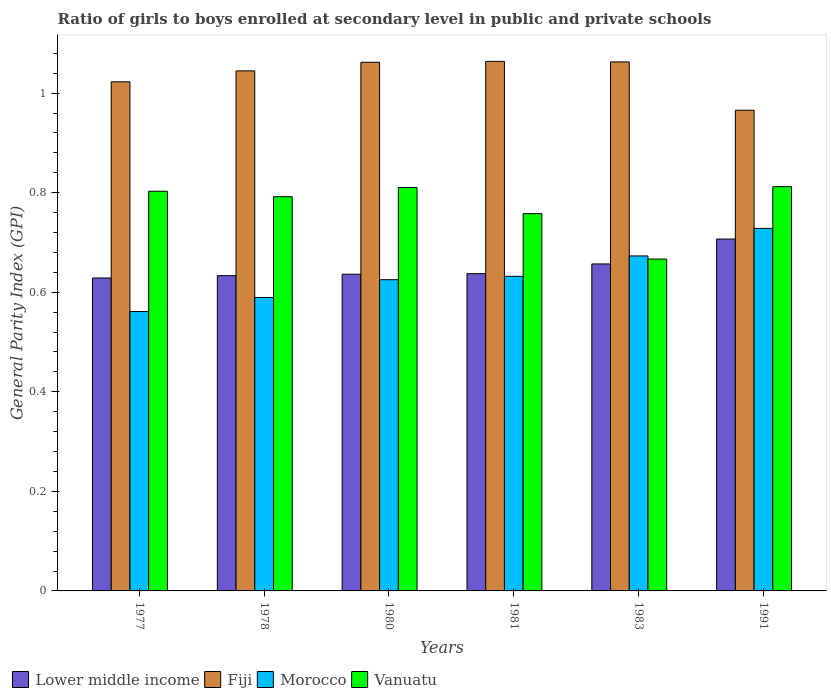What is the label of the 2nd group of bars from the left?
Offer a very short reply. 1978. What is the general parity index in Fiji in 1981?
Give a very brief answer. 1.06. Across all years, what is the maximum general parity index in Fiji?
Give a very brief answer. 1.06. Across all years, what is the minimum general parity index in Fiji?
Keep it short and to the point. 0.97. In which year was the general parity index in Lower middle income maximum?
Your answer should be compact. 1991. What is the total general parity index in Lower middle income in the graph?
Offer a very short reply. 3.9. What is the difference between the general parity index in Lower middle income in 1983 and that in 1991?
Offer a terse response. -0.05. What is the difference between the general parity index in Fiji in 1977 and the general parity index in Vanuatu in 1980?
Ensure brevity in your answer.  0.21. What is the average general parity index in Morocco per year?
Keep it short and to the point. 0.63. In the year 1983, what is the difference between the general parity index in Fiji and general parity index in Morocco?
Your answer should be very brief. 0.39. What is the ratio of the general parity index in Fiji in 1977 to that in 1983?
Keep it short and to the point. 0.96. Is the general parity index in Fiji in 1980 less than that in 1981?
Your answer should be compact. Yes. Is the difference between the general parity index in Fiji in 1977 and 1980 greater than the difference between the general parity index in Morocco in 1977 and 1980?
Offer a very short reply. Yes. What is the difference between the highest and the second highest general parity index in Vanuatu?
Ensure brevity in your answer.  0. What is the difference between the highest and the lowest general parity index in Vanuatu?
Your answer should be compact. 0.15. Is it the case that in every year, the sum of the general parity index in Morocco and general parity index in Vanuatu is greater than the sum of general parity index in Lower middle income and general parity index in Fiji?
Your response must be concise. Yes. What does the 1st bar from the left in 1978 represents?
Your answer should be compact. Lower middle income. What does the 1st bar from the right in 1991 represents?
Your answer should be very brief. Vanuatu. Is it the case that in every year, the sum of the general parity index in Lower middle income and general parity index in Fiji is greater than the general parity index in Morocco?
Keep it short and to the point. Yes. How many bars are there?
Offer a very short reply. 24. How many years are there in the graph?
Ensure brevity in your answer.  6. Are the values on the major ticks of Y-axis written in scientific E-notation?
Provide a short and direct response. No. Does the graph contain grids?
Keep it short and to the point. No. Where does the legend appear in the graph?
Provide a short and direct response. Bottom left. How are the legend labels stacked?
Your answer should be compact. Horizontal. What is the title of the graph?
Your answer should be compact. Ratio of girls to boys enrolled at secondary level in public and private schools. What is the label or title of the X-axis?
Make the answer very short. Years. What is the label or title of the Y-axis?
Provide a short and direct response. General Parity Index (GPI). What is the General Parity Index (GPI) in Lower middle income in 1977?
Ensure brevity in your answer.  0.63. What is the General Parity Index (GPI) of Fiji in 1977?
Ensure brevity in your answer.  1.02. What is the General Parity Index (GPI) of Morocco in 1977?
Provide a short and direct response. 0.56. What is the General Parity Index (GPI) in Vanuatu in 1977?
Your response must be concise. 0.8. What is the General Parity Index (GPI) of Lower middle income in 1978?
Give a very brief answer. 0.63. What is the General Parity Index (GPI) of Fiji in 1978?
Ensure brevity in your answer.  1.04. What is the General Parity Index (GPI) of Morocco in 1978?
Keep it short and to the point. 0.59. What is the General Parity Index (GPI) of Vanuatu in 1978?
Offer a terse response. 0.79. What is the General Parity Index (GPI) in Lower middle income in 1980?
Give a very brief answer. 0.64. What is the General Parity Index (GPI) of Fiji in 1980?
Provide a short and direct response. 1.06. What is the General Parity Index (GPI) in Morocco in 1980?
Offer a very short reply. 0.63. What is the General Parity Index (GPI) in Vanuatu in 1980?
Ensure brevity in your answer.  0.81. What is the General Parity Index (GPI) of Lower middle income in 1981?
Offer a very short reply. 0.64. What is the General Parity Index (GPI) in Fiji in 1981?
Make the answer very short. 1.06. What is the General Parity Index (GPI) in Morocco in 1981?
Your response must be concise. 0.63. What is the General Parity Index (GPI) of Vanuatu in 1981?
Provide a short and direct response. 0.76. What is the General Parity Index (GPI) in Lower middle income in 1983?
Give a very brief answer. 0.66. What is the General Parity Index (GPI) of Fiji in 1983?
Provide a short and direct response. 1.06. What is the General Parity Index (GPI) in Morocco in 1983?
Your answer should be compact. 0.67. What is the General Parity Index (GPI) of Vanuatu in 1983?
Provide a succinct answer. 0.67. What is the General Parity Index (GPI) in Lower middle income in 1991?
Make the answer very short. 0.71. What is the General Parity Index (GPI) of Fiji in 1991?
Provide a short and direct response. 0.97. What is the General Parity Index (GPI) of Morocco in 1991?
Provide a short and direct response. 0.73. What is the General Parity Index (GPI) of Vanuatu in 1991?
Provide a short and direct response. 0.81. Across all years, what is the maximum General Parity Index (GPI) in Lower middle income?
Provide a short and direct response. 0.71. Across all years, what is the maximum General Parity Index (GPI) of Fiji?
Provide a short and direct response. 1.06. Across all years, what is the maximum General Parity Index (GPI) in Morocco?
Keep it short and to the point. 0.73. Across all years, what is the maximum General Parity Index (GPI) of Vanuatu?
Ensure brevity in your answer.  0.81. Across all years, what is the minimum General Parity Index (GPI) in Lower middle income?
Give a very brief answer. 0.63. Across all years, what is the minimum General Parity Index (GPI) of Fiji?
Provide a short and direct response. 0.97. Across all years, what is the minimum General Parity Index (GPI) of Morocco?
Provide a succinct answer. 0.56. Across all years, what is the minimum General Parity Index (GPI) in Vanuatu?
Make the answer very short. 0.67. What is the total General Parity Index (GPI) in Lower middle income in the graph?
Your response must be concise. 3.9. What is the total General Parity Index (GPI) of Fiji in the graph?
Provide a short and direct response. 6.22. What is the total General Parity Index (GPI) in Morocco in the graph?
Provide a succinct answer. 3.81. What is the total General Parity Index (GPI) in Vanuatu in the graph?
Provide a short and direct response. 4.64. What is the difference between the General Parity Index (GPI) of Lower middle income in 1977 and that in 1978?
Provide a succinct answer. -0. What is the difference between the General Parity Index (GPI) of Fiji in 1977 and that in 1978?
Ensure brevity in your answer.  -0.02. What is the difference between the General Parity Index (GPI) of Morocco in 1977 and that in 1978?
Provide a succinct answer. -0.03. What is the difference between the General Parity Index (GPI) in Vanuatu in 1977 and that in 1978?
Offer a very short reply. 0.01. What is the difference between the General Parity Index (GPI) of Lower middle income in 1977 and that in 1980?
Make the answer very short. -0.01. What is the difference between the General Parity Index (GPI) in Fiji in 1977 and that in 1980?
Give a very brief answer. -0.04. What is the difference between the General Parity Index (GPI) of Morocco in 1977 and that in 1980?
Give a very brief answer. -0.06. What is the difference between the General Parity Index (GPI) in Vanuatu in 1977 and that in 1980?
Keep it short and to the point. -0.01. What is the difference between the General Parity Index (GPI) in Lower middle income in 1977 and that in 1981?
Provide a short and direct response. -0.01. What is the difference between the General Parity Index (GPI) of Fiji in 1977 and that in 1981?
Your response must be concise. -0.04. What is the difference between the General Parity Index (GPI) of Morocco in 1977 and that in 1981?
Your answer should be very brief. -0.07. What is the difference between the General Parity Index (GPI) of Vanuatu in 1977 and that in 1981?
Provide a short and direct response. 0.04. What is the difference between the General Parity Index (GPI) of Lower middle income in 1977 and that in 1983?
Provide a succinct answer. -0.03. What is the difference between the General Parity Index (GPI) of Fiji in 1977 and that in 1983?
Offer a very short reply. -0.04. What is the difference between the General Parity Index (GPI) of Morocco in 1977 and that in 1983?
Provide a succinct answer. -0.11. What is the difference between the General Parity Index (GPI) in Vanuatu in 1977 and that in 1983?
Your answer should be compact. 0.14. What is the difference between the General Parity Index (GPI) in Lower middle income in 1977 and that in 1991?
Make the answer very short. -0.08. What is the difference between the General Parity Index (GPI) of Fiji in 1977 and that in 1991?
Keep it short and to the point. 0.06. What is the difference between the General Parity Index (GPI) of Morocco in 1977 and that in 1991?
Make the answer very short. -0.17. What is the difference between the General Parity Index (GPI) in Vanuatu in 1977 and that in 1991?
Your answer should be very brief. -0.01. What is the difference between the General Parity Index (GPI) in Lower middle income in 1978 and that in 1980?
Provide a short and direct response. -0. What is the difference between the General Parity Index (GPI) in Fiji in 1978 and that in 1980?
Give a very brief answer. -0.02. What is the difference between the General Parity Index (GPI) of Morocco in 1978 and that in 1980?
Provide a short and direct response. -0.04. What is the difference between the General Parity Index (GPI) of Vanuatu in 1978 and that in 1980?
Offer a terse response. -0.02. What is the difference between the General Parity Index (GPI) in Lower middle income in 1978 and that in 1981?
Provide a short and direct response. -0. What is the difference between the General Parity Index (GPI) of Fiji in 1978 and that in 1981?
Offer a very short reply. -0.02. What is the difference between the General Parity Index (GPI) in Morocco in 1978 and that in 1981?
Ensure brevity in your answer.  -0.04. What is the difference between the General Parity Index (GPI) of Vanuatu in 1978 and that in 1981?
Your answer should be compact. 0.03. What is the difference between the General Parity Index (GPI) in Lower middle income in 1978 and that in 1983?
Offer a very short reply. -0.02. What is the difference between the General Parity Index (GPI) in Fiji in 1978 and that in 1983?
Ensure brevity in your answer.  -0.02. What is the difference between the General Parity Index (GPI) of Morocco in 1978 and that in 1983?
Offer a terse response. -0.08. What is the difference between the General Parity Index (GPI) of Vanuatu in 1978 and that in 1983?
Your answer should be very brief. 0.13. What is the difference between the General Parity Index (GPI) of Lower middle income in 1978 and that in 1991?
Ensure brevity in your answer.  -0.07. What is the difference between the General Parity Index (GPI) of Fiji in 1978 and that in 1991?
Provide a short and direct response. 0.08. What is the difference between the General Parity Index (GPI) of Morocco in 1978 and that in 1991?
Provide a short and direct response. -0.14. What is the difference between the General Parity Index (GPI) in Vanuatu in 1978 and that in 1991?
Give a very brief answer. -0.02. What is the difference between the General Parity Index (GPI) of Lower middle income in 1980 and that in 1981?
Keep it short and to the point. -0. What is the difference between the General Parity Index (GPI) in Fiji in 1980 and that in 1981?
Your response must be concise. -0. What is the difference between the General Parity Index (GPI) in Morocco in 1980 and that in 1981?
Offer a very short reply. -0.01. What is the difference between the General Parity Index (GPI) in Vanuatu in 1980 and that in 1981?
Your response must be concise. 0.05. What is the difference between the General Parity Index (GPI) in Lower middle income in 1980 and that in 1983?
Ensure brevity in your answer.  -0.02. What is the difference between the General Parity Index (GPI) in Fiji in 1980 and that in 1983?
Give a very brief answer. -0. What is the difference between the General Parity Index (GPI) of Morocco in 1980 and that in 1983?
Your response must be concise. -0.05. What is the difference between the General Parity Index (GPI) of Vanuatu in 1980 and that in 1983?
Give a very brief answer. 0.14. What is the difference between the General Parity Index (GPI) of Lower middle income in 1980 and that in 1991?
Ensure brevity in your answer.  -0.07. What is the difference between the General Parity Index (GPI) of Fiji in 1980 and that in 1991?
Ensure brevity in your answer.  0.1. What is the difference between the General Parity Index (GPI) of Morocco in 1980 and that in 1991?
Provide a succinct answer. -0.1. What is the difference between the General Parity Index (GPI) of Vanuatu in 1980 and that in 1991?
Provide a short and direct response. -0. What is the difference between the General Parity Index (GPI) of Lower middle income in 1981 and that in 1983?
Ensure brevity in your answer.  -0.02. What is the difference between the General Parity Index (GPI) in Fiji in 1981 and that in 1983?
Give a very brief answer. 0. What is the difference between the General Parity Index (GPI) in Morocco in 1981 and that in 1983?
Ensure brevity in your answer.  -0.04. What is the difference between the General Parity Index (GPI) of Vanuatu in 1981 and that in 1983?
Provide a succinct answer. 0.09. What is the difference between the General Parity Index (GPI) in Lower middle income in 1981 and that in 1991?
Make the answer very short. -0.07. What is the difference between the General Parity Index (GPI) in Fiji in 1981 and that in 1991?
Make the answer very short. 0.1. What is the difference between the General Parity Index (GPI) in Morocco in 1981 and that in 1991?
Give a very brief answer. -0.1. What is the difference between the General Parity Index (GPI) of Vanuatu in 1981 and that in 1991?
Offer a terse response. -0.05. What is the difference between the General Parity Index (GPI) in Lower middle income in 1983 and that in 1991?
Keep it short and to the point. -0.05. What is the difference between the General Parity Index (GPI) in Fiji in 1983 and that in 1991?
Offer a terse response. 0.1. What is the difference between the General Parity Index (GPI) in Morocco in 1983 and that in 1991?
Provide a short and direct response. -0.06. What is the difference between the General Parity Index (GPI) of Vanuatu in 1983 and that in 1991?
Keep it short and to the point. -0.15. What is the difference between the General Parity Index (GPI) in Lower middle income in 1977 and the General Parity Index (GPI) in Fiji in 1978?
Provide a succinct answer. -0.42. What is the difference between the General Parity Index (GPI) in Lower middle income in 1977 and the General Parity Index (GPI) in Morocco in 1978?
Give a very brief answer. 0.04. What is the difference between the General Parity Index (GPI) in Lower middle income in 1977 and the General Parity Index (GPI) in Vanuatu in 1978?
Your answer should be very brief. -0.16. What is the difference between the General Parity Index (GPI) of Fiji in 1977 and the General Parity Index (GPI) of Morocco in 1978?
Your answer should be very brief. 0.43. What is the difference between the General Parity Index (GPI) in Fiji in 1977 and the General Parity Index (GPI) in Vanuatu in 1978?
Ensure brevity in your answer.  0.23. What is the difference between the General Parity Index (GPI) of Morocco in 1977 and the General Parity Index (GPI) of Vanuatu in 1978?
Keep it short and to the point. -0.23. What is the difference between the General Parity Index (GPI) of Lower middle income in 1977 and the General Parity Index (GPI) of Fiji in 1980?
Give a very brief answer. -0.43. What is the difference between the General Parity Index (GPI) of Lower middle income in 1977 and the General Parity Index (GPI) of Morocco in 1980?
Offer a terse response. 0. What is the difference between the General Parity Index (GPI) of Lower middle income in 1977 and the General Parity Index (GPI) of Vanuatu in 1980?
Provide a short and direct response. -0.18. What is the difference between the General Parity Index (GPI) in Fiji in 1977 and the General Parity Index (GPI) in Morocco in 1980?
Provide a succinct answer. 0.4. What is the difference between the General Parity Index (GPI) in Fiji in 1977 and the General Parity Index (GPI) in Vanuatu in 1980?
Offer a very short reply. 0.21. What is the difference between the General Parity Index (GPI) in Morocco in 1977 and the General Parity Index (GPI) in Vanuatu in 1980?
Keep it short and to the point. -0.25. What is the difference between the General Parity Index (GPI) in Lower middle income in 1977 and the General Parity Index (GPI) in Fiji in 1981?
Make the answer very short. -0.44. What is the difference between the General Parity Index (GPI) in Lower middle income in 1977 and the General Parity Index (GPI) in Morocco in 1981?
Keep it short and to the point. -0. What is the difference between the General Parity Index (GPI) in Lower middle income in 1977 and the General Parity Index (GPI) in Vanuatu in 1981?
Provide a short and direct response. -0.13. What is the difference between the General Parity Index (GPI) of Fiji in 1977 and the General Parity Index (GPI) of Morocco in 1981?
Make the answer very short. 0.39. What is the difference between the General Parity Index (GPI) of Fiji in 1977 and the General Parity Index (GPI) of Vanuatu in 1981?
Give a very brief answer. 0.26. What is the difference between the General Parity Index (GPI) of Morocco in 1977 and the General Parity Index (GPI) of Vanuatu in 1981?
Ensure brevity in your answer.  -0.2. What is the difference between the General Parity Index (GPI) in Lower middle income in 1977 and the General Parity Index (GPI) in Fiji in 1983?
Give a very brief answer. -0.43. What is the difference between the General Parity Index (GPI) of Lower middle income in 1977 and the General Parity Index (GPI) of Morocco in 1983?
Offer a very short reply. -0.04. What is the difference between the General Parity Index (GPI) in Lower middle income in 1977 and the General Parity Index (GPI) in Vanuatu in 1983?
Ensure brevity in your answer.  -0.04. What is the difference between the General Parity Index (GPI) of Fiji in 1977 and the General Parity Index (GPI) of Morocco in 1983?
Your answer should be very brief. 0.35. What is the difference between the General Parity Index (GPI) in Fiji in 1977 and the General Parity Index (GPI) in Vanuatu in 1983?
Provide a succinct answer. 0.36. What is the difference between the General Parity Index (GPI) in Morocco in 1977 and the General Parity Index (GPI) in Vanuatu in 1983?
Make the answer very short. -0.11. What is the difference between the General Parity Index (GPI) of Lower middle income in 1977 and the General Parity Index (GPI) of Fiji in 1991?
Your answer should be very brief. -0.34. What is the difference between the General Parity Index (GPI) of Lower middle income in 1977 and the General Parity Index (GPI) of Morocco in 1991?
Offer a very short reply. -0.1. What is the difference between the General Parity Index (GPI) of Lower middle income in 1977 and the General Parity Index (GPI) of Vanuatu in 1991?
Give a very brief answer. -0.18. What is the difference between the General Parity Index (GPI) in Fiji in 1977 and the General Parity Index (GPI) in Morocco in 1991?
Provide a short and direct response. 0.29. What is the difference between the General Parity Index (GPI) of Fiji in 1977 and the General Parity Index (GPI) of Vanuatu in 1991?
Provide a short and direct response. 0.21. What is the difference between the General Parity Index (GPI) in Morocco in 1977 and the General Parity Index (GPI) in Vanuatu in 1991?
Your answer should be compact. -0.25. What is the difference between the General Parity Index (GPI) of Lower middle income in 1978 and the General Parity Index (GPI) of Fiji in 1980?
Your response must be concise. -0.43. What is the difference between the General Parity Index (GPI) in Lower middle income in 1978 and the General Parity Index (GPI) in Morocco in 1980?
Your response must be concise. 0.01. What is the difference between the General Parity Index (GPI) in Lower middle income in 1978 and the General Parity Index (GPI) in Vanuatu in 1980?
Your answer should be very brief. -0.18. What is the difference between the General Parity Index (GPI) of Fiji in 1978 and the General Parity Index (GPI) of Morocco in 1980?
Provide a short and direct response. 0.42. What is the difference between the General Parity Index (GPI) of Fiji in 1978 and the General Parity Index (GPI) of Vanuatu in 1980?
Give a very brief answer. 0.23. What is the difference between the General Parity Index (GPI) of Morocco in 1978 and the General Parity Index (GPI) of Vanuatu in 1980?
Provide a short and direct response. -0.22. What is the difference between the General Parity Index (GPI) in Lower middle income in 1978 and the General Parity Index (GPI) in Fiji in 1981?
Offer a very short reply. -0.43. What is the difference between the General Parity Index (GPI) in Lower middle income in 1978 and the General Parity Index (GPI) in Morocco in 1981?
Your answer should be very brief. 0. What is the difference between the General Parity Index (GPI) of Lower middle income in 1978 and the General Parity Index (GPI) of Vanuatu in 1981?
Your answer should be very brief. -0.12. What is the difference between the General Parity Index (GPI) of Fiji in 1978 and the General Parity Index (GPI) of Morocco in 1981?
Your answer should be very brief. 0.41. What is the difference between the General Parity Index (GPI) in Fiji in 1978 and the General Parity Index (GPI) in Vanuatu in 1981?
Your response must be concise. 0.29. What is the difference between the General Parity Index (GPI) of Morocco in 1978 and the General Parity Index (GPI) of Vanuatu in 1981?
Offer a terse response. -0.17. What is the difference between the General Parity Index (GPI) in Lower middle income in 1978 and the General Parity Index (GPI) in Fiji in 1983?
Your response must be concise. -0.43. What is the difference between the General Parity Index (GPI) in Lower middle income in 1978 and the General Parity Index (GPI) in Morocco in 1983?
Provide a short and direct response. -0.04. What is the difference between the General Parity Index (GPI) in Lower middle income in 1978 and the General Parity Index (GPI) in Vanuatu in 1983?
Your answer should be very brief. -0.03. What is the difference between the General Parity Index (GPI) in Fiji in 1978 and the General Parity Index (GPI) in Morocco in 1983?
Keep it short and to the point. 0.37. What is the difference between the General Parity Index (GPI) of Fiji in 1978 and the General Parity Index (GPI) of Vanuatu in 1983?
Provide a succinct answer. 0.38. What is the difference between the General Parity Index (GPI) in Morocco in 1978 and the General Parity Index (GPI) in Vanuatu in 1983?
Give a very brief answer. -0.08. What is the difference between the General Parity Index (GPI) of Lower middle income in 1978 and the General Parity Index (GPI) of Fiji in 1991?
Your answer should be very brief. -0.33. What is the difference between the General Parity Index (GPI) in Lower middle income in 1978 and the General Parity Index (GPI) in Morocco in 1991?
Give a very brief answer. -0.1. What is the difference between the General Parity Index (GPI) of Lower middle income in 1978 and the General Parity Index (GPI) of Vanuatu in 1991?
Your answer should be very brief. -0.18. What is the difference between the General Parity Index (GPI) in Fiji in 1978 and the General Parity Index (GPI) in Morocco in 1991?
Keep it short and to the point. 0.32. What is the difference between the General Parity Index (GPI) in Fiji in 1978 and the General Parity Index (GPI) in Vanuatu in 1991?
Provide a short and direct response. 0.23. What is the difference between the General Parity Index (GPI) of Morocco in 1978 and the General Parity Index (GPI) of Vanuatu in 1991?
Your answer should be very brief. -0.22. What is the difference between the General Parity Index (GPI) of Lower middle income in 1980 and the General Parity Index (GPI) of Fiji in 1981?
Offer a terse response. -0.43. What is the difference between the General Parity Index (GPI) in Lower middle income in 1980 and the General Parity Index (GPI) in Morocco in 1981?
Keep it short and to the point. 0. What is the difference between the General Parity Index (GPI) of Lower middle income in 1980 and the General Parity Index (GPI) of Vanuatu in 1981?
Keep it short and to the point. -0.12. What is the difference between the General Parity Index (GPI) of Fiji in 1980 and the General Parity Index (GPI) of Morocco in 1981?
Offer a very short reply. 0.43. What is the difference between the General Parity Index (GPI) in Fiji in 1980 and the General Parity Index (GPI) in Vanuatu in 1981?
Keep it short and to the point. 0.3. What is the difference between the General Parity Index (GPI) in Morocco in 1980 and the General Parity Index (GPI) in Vanuatu in 1981?
Give a very brief answer. -0.13. What is the difference between the General Parity Index (GPI) of Lower middle income in 1980 and the General Parity Index (GPI) of Fiji in 1983?
Your answer should be very brief. -0.43. What is the difference between the General Parity Index (GPI) of Lower middle income in 1980 and the General Parity Index (GPI) of Morocco in 1983?
Your answer should be compact. -0.04. What is the difference between the General Parity Index (GPI) in Lower middle income in 1980 and the General Parity Index (GPI) in Vanuatu in 1983?
Give a very brief answer. -0.03. What is the difference between the General Parity Index (GPI) in Fiji in 1980 and the General Parity Index (GPI) in Morocco in 1983?
Ensure brevity in your answer.  0.39. What is the difference between the General Parity Index (GPI) of Fiji in 1980 and the General Parity Index (GPI) of Vanuatu in 1983?
Your response must be concise. 0.4. What is the difference between the General Parity Index (GPI) of Morocco in 1980 and the General Parity Index (GPI) of Vanuatu in 1983?
Give a very brief answer. -0.04. What is the difference between the General Parity Index (GPI) in Lower middle income in 1980 and the General Parity Index (GPI) in Fiji in 1991?
Your response must be concise. -0.33. What is the difference between the General Parity Index (GPI) of Lower middle income in 1980 and the General Parity Index (GPI) of Morocco in 1991?
Provide a succinct answer. -0.09. What is the difference between the General Parity Index (GPI) of Lower middle income in 1980 and the General Parity Index (GPI) of Vanuatu in 1991?
Ensure brevity in your answer.  -0.18. What is the difference between the General Parity Index (GPI) of Fiji in 1980 and the General Parity Index (GPI) of Morocco in 1991?
Offer a very short reply. 0.33. What is the difference between the General Parity Index (GPI) in Fiji in 1980 and the General Parity Index (GPI) in Vanuatu in 1991?
Provide a short and direct response. 0.25. What is the difference between the General Parity Index (GPI) of Morocco in 1980 and the General Parity Index (GPI) of Vanuatu in 1991?
Provide a succinct answer. -0.19. What is the difference between the General Parity Index (GPI) of Lower middle income in 1981 and the General Parity Index (GPI) of Fiji in 1983?
Ensure brevity in your answer.  -0.43. What is the difference between the General Parity Index (GPI) of Lower middle income in 1981 and the General Parity Index (GPI) of Morocco in 1983?
Keep it short and to the point. -0.04. What is the difference between the General Parity Index (GPI) of Lower middle income in 1981 and the General Parity Index (GPI) of Vanuatu in 1983?
Offer a very short reply. -0.03. What is the difference between the General Parity Index (GPI) in Fiji in 1981 and the General Parity Index (GPI) in Morocco in 1983?
Your response must be concise. 0.39. What is the difference between the General Parity Index (GPI) of Fiji in 1981 and the General Parity Index (GPI) of Vanuatu in 1983?
Keep it short and to the point. 0.4. What is the difference between the General Parity Index (GPI) of Morocco in 1981 and the General Parity Index (GPI) of Vanuatu in 1983?
Offer a terse response. -0.03. What is the difference between the General Parity Index (GPI) in Lower middle income in 1981 and the General Parity Index (GPI) in Fiji in 1991?
Ensure brevity in your answer.  -0.33. What is the difference between the General Parity Index (GPI) of Lower middle income in 1981 and the General Parity Index (GPI) of Morocco in 1991?
Your answer should be very brief. -0.09. What is the difference between the General Parity Index (GPI) in Lower middle income in 1981 and the General Parity Index (GPI) in Vanuatu in 1991?
Your answer should be compact. -0.17. What is the difference between the General Parity Index (GPI) of Fiji in 1981 and the General Parity Index (GPI) of Morocco in 1991?
Offer a very short reply. 0.34. What is the difference between the General Parity Index (GPI) of Fiji in 1981 and the General Parity Index (GPI) of Vanuatu in 1991?
Keep it short and to the point. 0.25. What is the difference between the General Parity Index (GPI) in Morocco in 1981 and the General Parity Index (GPI) in Vanuatu in 1991?
Your answer should be compact. -0.18. What is the difference between the General Parity Index (GPI) in Lower middle income in 1983 and the General Parity Index (GPI) in Fiji in 1991?
Provide a succinct answer. -0.31. What is the difference between the General Parity Index (GPI) in Lower middle income in 1983 and the General Parity Index (GPI) in Morocco in 1991?
Offer a very short reply. -0.07. What is the difference between the General Parity Index (GPI) of Lower middle income in 1983 and the General Parity Index (GPI) of Vanuatu in 1991?
Your answer should be compact. -0.16. What is the difference between the General Parity Index (GPI) of Fiji in 1983 and the General Parity Index (GPI) of Morocco in 1991?
Your answer should be compact. 0.33. What is the difference between the General Parity Index (GPI) of Fiji in 1983 and the General Parity Index (GPI) of Vanuatu in 1991?
Ensure brevity in your answer.  0.25. What is the difference between the General Parity Index (GPI) of Morocco in 1983 and the General Parity Index (GPI) of Vanuatu in 1991?
Make the answer very short. -0.14. What is the average General Parity Index (GPI) of Lower middle income per year?
Keep it short and to the point. 0.65. What is the average General Parity Index (GPI) of Fiji per year?
Make the answer very short. 1.04. What is the average General Parity Index (GPI) in Morocco per year?
Provide a succinct answer. 0.63. What is the average General Parity Index (GPI) of Vanuatu per year?
Your answer should be very brief. 0.77. In the year 1977, what is the difference between the General Parity Index (GPI) of Lower middle income and General Parity Index (GPI) of Fiji?
Offer a very short reply. -0.39. In the year 1977, what is the difference between the General Parity Index (GPI) of Lower middle income and General Parity Index (GPI) of Morocco?
Offer a very short reply. 0.07. In the year 1977, what is the difference between the General Parity Index (GPI) in Lower middle income and General Parity Index (GPI) in Vanuatu?
Provide a short and direct response. -0.17. In the year 1977, what is the difference between the General Parity Index (GPI) of Fiji and General Parity Index (GPI) of Morocco?
Provide a succinct answer. 0.46. In the year 1977, what is the difference between the General Parity Index (GPI) of Fiji and General Parity Index (GPI) of Vanuatu?
Your answer should be compact. 0.22. In the year 1977, what is the difference between the General Parity Index (GPI) of Morocco and General Parity Index (GPI) of Vanuatu?
Make the answer very short. -0.24. In the year 1978, what is the difference between the General Parity Index (GPI) of Lower middle income and General Parity Index (GPI) of Fiji?
Your response must be concise. -0.41. In the year 1978, what is the difference between the General Parity Index (GPI) in Lower middle income and General Parity Index (GPI) in Morocco?
Provide a short and direct response. 0.04. In the year 1978, what is the difference between the General Parity Index (GPI) in Lower middle income and General Parity Index (GPI) in Vanuatu?
Give a very brief answer. -0.16. In the year 1978, what is the difference between the General Parity Index (GPI) of Fiji and General Parity Index (GPI) of Morocco?
Give a very brief answer. 0.46. In the year 1978, what is the difference between the General Parity Index (GPI) in Fiji and General Parity Index (GPI) in Vanuatu?
Give a very brief answer. 0.25. In the year 1978, what is the difference between the General Parity Index (GPI) in Morocco and General Parity Index (GPI) in Vanuatu?
Keep it short and to the point. -0.2. In the year 1980, what is the difference between the General Parity Index (GPI) of Lower middle income and General Parity Index (GPI) of Fiji?
Provide a short and direct response. -0.43. In the year 1980, what is the difference between the General Parity Index (GPI) of Lower middle income and General Parity Index (GPI) of Morocco?
Your response must be concise. 0.01. In the year 1980, what is the difference between the General Parity Index (GPI) in Lower middle income and General Parity Index (GPI) in Vanuatu?
Ensure brevity in your answer.  -0.17. In the year 1980, what is the difference between the General Parity Index (GPI) in Fiji and General Parity Index (GPI) in Morocco?
Offer a very short reply. 0.44. In the year 1980, what is the difference between the General Parity Index (GPI) of Fiji and General Parity Index (GPI) of Vanuatu?
Your response must be concise. 0.25. In the year 1980, what is the difference between the General Parity Index (GPI) of Morocco and General Parity Index (GPI) of Vanuatu?
Make the answer very short. -0.19. In the year 1981, what is the difference between the General Parity Index (GPI) of Lower middle income and General Parity Index (GPI) of Fiji?
Offer a terse response. -0.43. In the year 1981, what is the difference between the General Parity Index (GPI) of Lower middle income and General Parity Index (GPI) of Morocco?
Provide a short and direct response. 0.01. In the year 1981, what is the difference between the General Parity Index (GPI) in Lower middle income and General Parity Index (GPI) in Vanuatu?
Your response must be concise. -0.12. In the year 1981, what is the difference between the General Parity Index (GPI) of Fiji and General Parity Index (GPI) of Morocco?
Offer a terse response. 0.43. In the year 1981, what is the difference between the General Parity Index (GPI) of Fiji and General Parity Index (GPI) of Vanuatu?
Give a very brief answer. 0.31. In the year 1981, what is the difference between the General Parity Index (GPI) of Morocco and General Parity Index (GPI) of Vanuatu?
Make the answer very short. -0.13. In the year 1983, what is the difference between the General Parity Index (GPI) in Lower middle income and General Parity Index (GPI) in Fiji?
Give a very brief answer. -0.41. In the year 1983, what is the difference between the General Parity Index (GPI) of Lower middle income and General Parity Index (GPI) of Morocco?
Ensure brevity in your answer.  -0.02. In the year 1983, what is the difference between the General Parity Index (GPI) of Lower middle income and General Parity Index (GPI) of Vanuatu?
Give a very brief answer. -0.01. In the year 1983, what is the difference between the General Parity Index (GPI) of Fiji and General Parity Index (GPI) of Morocco?
Make the answer very short. 0.39. In the year 1983, what is the difference between the General Parity Index (GPI) in Fiji and General Parity Index (GPI) in Vanuatu?
Your answer should be compact. 0.4. In the year 1983, what is the difference between the General Parity Index (GPI) of Morocco and General Parity Index (GPI) of Vanuatu?
Offer a very short reply. 0.01. In the year 1991, what is the difference between the General Parity Index (GPI) in Lower middle income and General Parity Index (GPI) in Fiji?
Your answer should be very brief. -0.26. In the year 1991, what is the difference between the General Parity Index (GPI) of Lower middle income and General Parity Index (GPI) of Morocco?
Make the answer very short. -0.02. In the year 1991, what is the difference between the General Parity Index (GPI) in Lower middle income and General Parity Index (GPI) in Vanuatu?
Ensure brevity in your answer.  -0.11. In the year 1991, what is the difference between the General Parity Index (GPI) of Fiji and General Parity Index (GPI) of Morocco?
Provide a succinct answer. 0.24. In the year 1991, what is the difference between the General Parity Index (GPI) of Fiji and General Parity Index (GPI) of Vanuatu?
Make the answer very short. 0.15. In the year 1991, what is the difference between the General Parity Index (GPI) in Morocco and General Parity Index (GPI) in Vanuatu?
Make the answer very short. -0.08. What is the ratio of the General Parity Index (GPI) in Lower middle income in 1977 to that in 1978?
Provide a short and direct response. 0.99. What is the ratio of the General Parity Index (GPI) of Fiji in 1977 to that in 1978?
Offer a terse response. 0.98. What is the ratio of the General Parity Index (GPI) in Morocco in 1977 to that in 1978?
Keep it short and to the point. 0.95. What is the ratio of the General Parity Index (GPI) in Vanuatu in 1977 to that in 1978?
Your answer should be very brief. 1.01. What is the ratio of the General Parity Index (GPI) in Lower middle income in 1977 to that in 1980?
Make the answer very short. 0.99. What is the ratio of the General Parity Index (GPI) of Morocco in 1977 to that in 1980?
Provide a succinct answer. 0.9. What is the ratio of the General Parity Index (GPI) in Vanuatu in 1977 to that in 1980?
Your answer should be very brief. 0.99. What is the ratio of the General Parity Index (GPI) of Lower middle income in 1977 to that in 1981?
Give a very brief answer. 0.99. What is the ratio of the General Parity Index (GPI) in Fiji in 1977 to that in 1981?
Your answer should be compact. 0.96. What is the ratio of the General Parity Index (GPI) of Morocco in 1977 to that in 1981?
Provide a short and direct response. 0.89. What is the ratio of the General Parity Index (GPI) of Vanuatu in 1977 to that in 1981?
Offer a terse response. 1.06. What is the ratio of the General Parity Index (GPI) of Lower middle income in 1977 to that in 1983?
Provide a succinct answer. 0.96. What is the ratio of the General Parity Index (GPI) of Fiji in 1977 to that in 1983?
Provide a short and direct response. 0.96. What is the ratio of the General Parity Index (GPI) of Morocco in 1977 to that in 1983?
Your answer should be compact. 0.83. What is the ratio of the General Parity Index (GPI) of Vanuatu in 1977 to that in 1983?
Give a very brief answer. 1.2. What is the ratio of the General Parity Index (GPI) in Lower middle income in 1977 to that in 1991?
Offer a very short reply. 0.89. What is the ratio of the General Parity Index (GPI) in Fiji in 1977 to that in 1991?
Offer a terse response. 1.06. What is the ratio of the General Parity Index (GPI) of Morocco in 1977 to that in 1991?
Keep it short and to the point. 0.77. What is the ratio of the General Parity Index (GPI) of Vanuatu in 1977 to that in 1991?
Your response must be concise. 0.99. What is the ratio of the General Parity Index (GPI) of Lower middle income in 1978 to that in 1980?
Offer a terse response. 1. What is the ratio of the General Parity Index (GPI) in Fiji in 1978 to that in 1980?
Offer a terse response. 0.98. What is the ratio of the General Parity Index (GPI) of Morocco in 1978 to that in 1980?
Your response must be concise. 0.94. What is the ratio of the General Parity Index (GPI) of Vanuatu in 1978 to that in 1980?
Your response must be concise. 0.98. What is the ratio of the General Parity Index (GPI) in Morocco in 1978 to that in 1981?
Provide a short and direct response. 0.93. What is the ratio of the General Parity Index (GPI) of Vanuatu in 1978 to that in 1981?
Your answer should be very brief. 1.04. What is the ratio of the General Parity Index (GPI) of Lower middle income in 1978 to that in 1983?
Offer a very short reply. 0.96. What is the ratio of the General Parity Index (GPI) of Fiji in 1978 to that in 1983?
Keep it short and to the point. 0.98. What is the ratio of the General Parity Index (GPI) in Morocco in 1978 to that in 1983?
Offer a terse response. 0.88. What is the ratio of the General Parity Index (GPI) of Vanuatu in 1978 to that in 1983?
Provide a succinct answer. 1.19. What is the ratio of the General Parity Index (GPI) in Lower middle income in 1978 to that in 1991?
Keep it short and to the point. 0.9. What is the ratio of the General Parity Index (GPI) in Fiji in 1978 to that in 1991?
Offer a very short reply. 1.08. What is the ratio of the General Parity Index (GPI) of Morocco in 1978 to that in 1991?
Provide a succinct answer. 0.81. What is the ratio of the General Parity Index (GPI) in Vanuatu in 1978 to that in 1991?
Your answer should be compact. 0.98. What is the ratio of the General Parity Index (GPI) in Fiji in 1980 to that in 1981?
Keep it short and to the point. 1. What is the ratio of the General Parity Index (GPI) of Vanuatu in 1980 to that in 1981?
Your answer should be compact. 1.07. What is the ratio of the General Parity Index (GPI) in Lower middle income in 1980 to that in 1983?
Your response must be concise. 0.97. What is the ratio of the General Parity Index (GPI) of Fiji in 1980 to that in 1983?
Provide a succinct answer. 1. What is the ratio of the General Parity Index (GPI) of Morocco in 1980 to that in 1983?
Keep it short and to the point. 0.93. What is the ratio of the General Parity Index (GPI) in Vanuatu in 1980 to that in 1983?
Ensure brevity in your answer.  1.22. What is the ratio of the General Parity Index (GPI) of Lower middle income in 1980 to that in 1991?
Make the answer very short. 0.9. What is the ratio of the General Parity Index (GPI) in Fiji in 1980 to that in 1991?
Your response must be concise. 1.1. What is the ratio of the General Parity Index (GPI) in Morocco in 1980 to that in 1991?
Keep it short and to the point. 0.86. What is the ratio of the General Parity Index (GPI) of Lower middle income in 1981 to that in 1983?
Keep it short and to the point. 0.97. What is the ratio of the General Parity Index (GPI) in Fiji in 1981 to that in 1983?
Your answer should be very brief. 1. What is the ratio of the General Parity Index (GPI) of Morocco in 1981 to that in 1983?
Offer a very short reply. 0.94. What is the ratio of the General Parity Index (GPI) in Vanuatu in 1981 to that in 1983?
Provide a succinct answer. 1.14. What is the ratio of the General Parity Index (GPI) of Lower middle income in 1981 to that in 1991?
Provide a short and direct response. 0.9. What is the ratio of the General Parity Index (GPI) of Fiji in 1981 to that in 1991?
Your answer should be very brief. 1.1. What is the ratio of the General Parity Index (GPI) in Morocco in 1981 to that in 1991?
Ensure brevity in your answer.  0.87. What is the ratio of the General Parity Index (GPI) in Vanuatu in 1981 to that in 1991?
Ensure brevity in your answer.  0.93. What is the ratio of the General Parity Index (GPI) of Lower middle income in 1983 to that in 1991?
Give a very brief answer. 0.93. What is the ratio of the General Parity Index (GPI) of Fiji in 1983 to that in 1991?
Provide a short and direct response. 1.1. What is the ratio of the General Parity Index (GPI) in Morocco in 1983 to that in 1991?
Offer a very short reply. 0.92. What is the ratio of the General Parity Index (GPI) of Vanuatu in 1983 to that in 1991?
Provide a short and direct response. 0.82. What is the difference between the highest and the second highest General Parity Index (GPI) of Lower middle income?
Keep it short and to the point. 0.05. What is the difference between the highest and the second highest General Parity Index (GPI) of Fiji?
Ensure brevity in your answer.  0. What is the difference between the highest and the second highest General Parity Index (GPI) in Morocco?
Ensure brevity in your answer.  0.06. What is the difference between the highest and the second highest General Parity Index (GPI) of Vanuatu?
Provide a short and direct response. 0. What is the difference between the highest and the lowest General Parity Index (GPI) of Lower middle income?
Make the answer very short. 0.08. What is the difference between the highest and the lowest General Parity Index (GPI) in Fiji?
Make the answer very short. 0.1. What is the difference between the highest and the lowest General Parity Index (GPI) in Morocco?
Provide a short and direct response. 0.17. What is the difference between the highest and the lowest General Parity Index (GPI) in Vanuatu?
Your response must be concise. 0.15. 